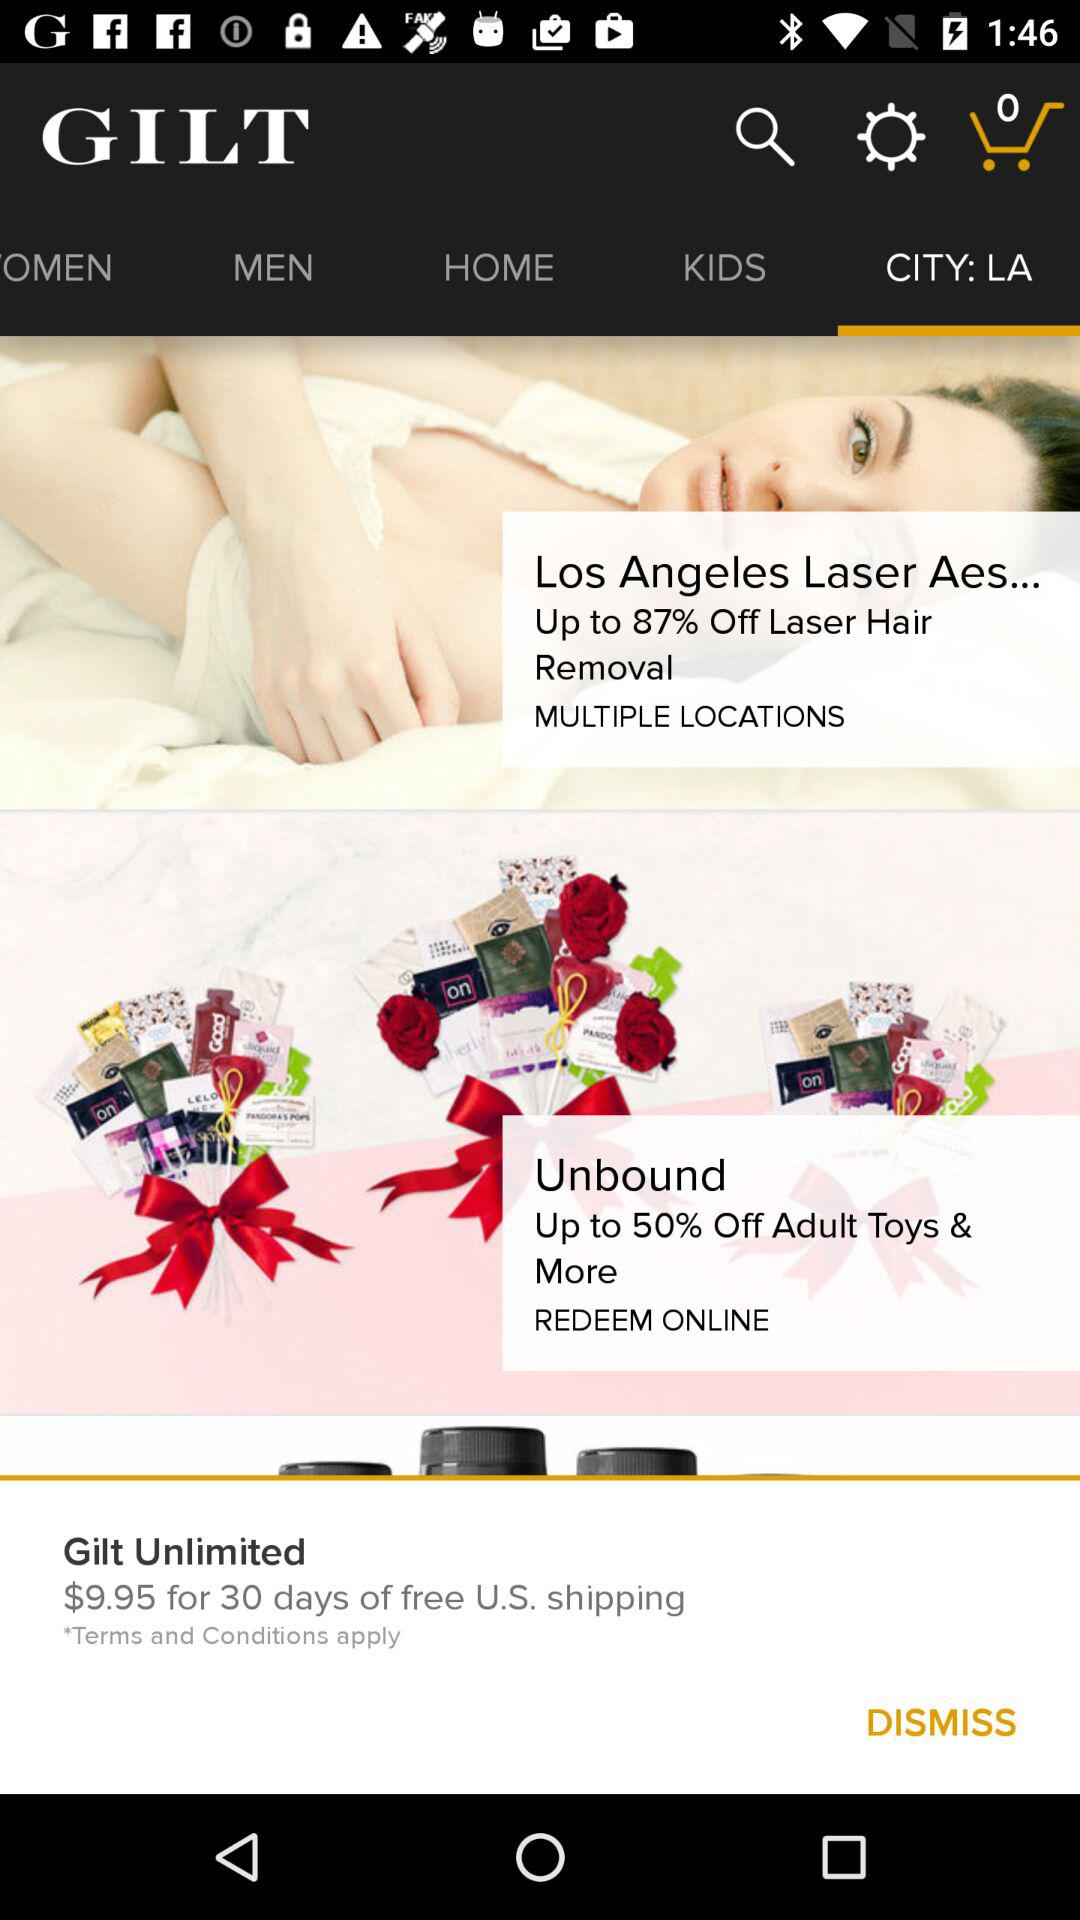What is the discount percentage on "Unbound" adult toys? The discount percentage is up to 50. 